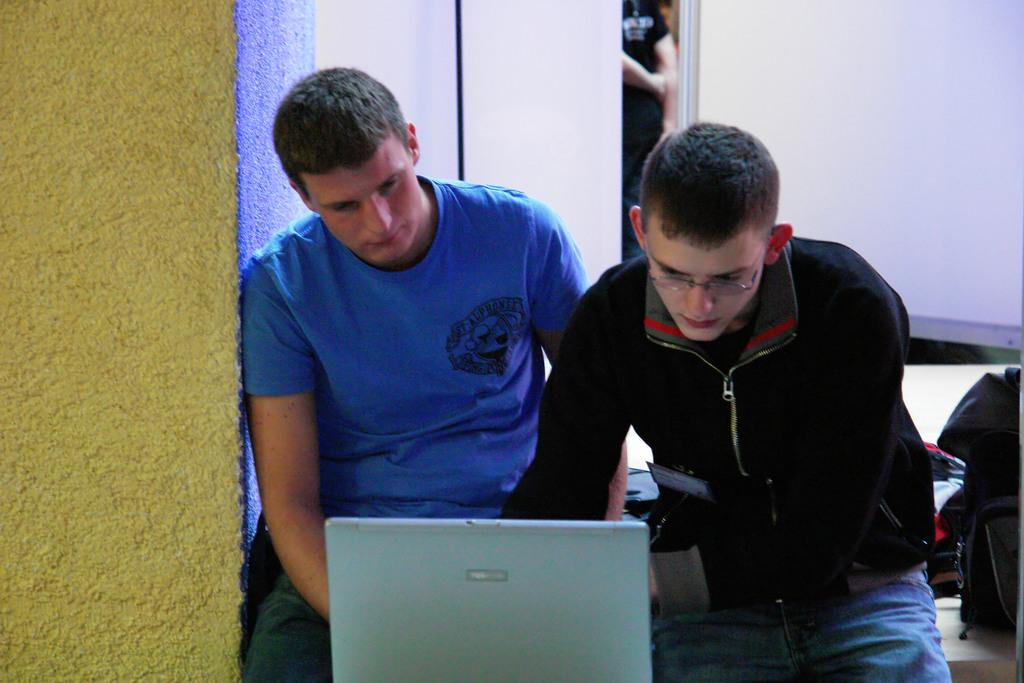How many people are in the image? There are two men in the picture. What are the men doing in the image? The men are sitting and operating a laptop. Can you describe any other objects or structures in the image? There is a pillar on the left side of the image. How does the distribution of the laptop affect the men's work in the image? There is no mention of a laptop distribution in the image, and the men are already operating the laptop. Can you see a car in the image? There is no car present in the image. 